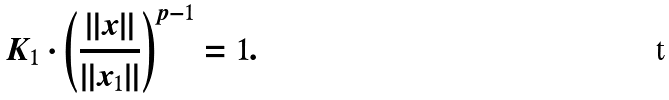<formula> <loc_0><loc_0><loc_500><loc_500>K _ { 1 } \cdot \left ( \frac { \| x \| } { \| x _ { 1 } \| } \right ) ^ { p - 1 } = 1 .</formula> 